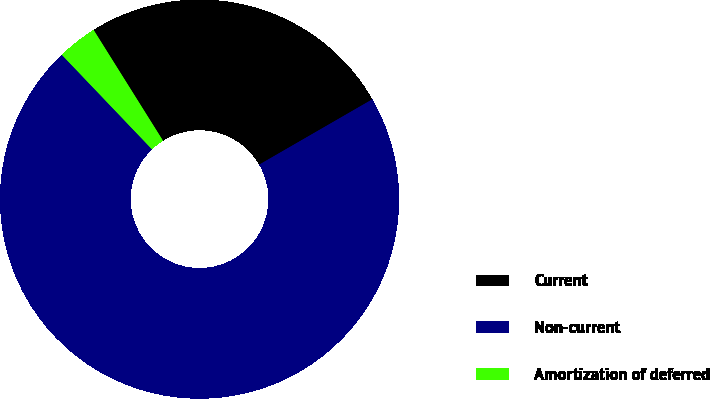Convert chart. <chart><loc_0><loc_0><loc_500><loc_500><pie_chart><fcel>Current<fcel>Non-current<fcel>Amortization of deferred<nl><fcel>25.57%<fcel>71.21%<fcel>3.22%<nl></chart> 